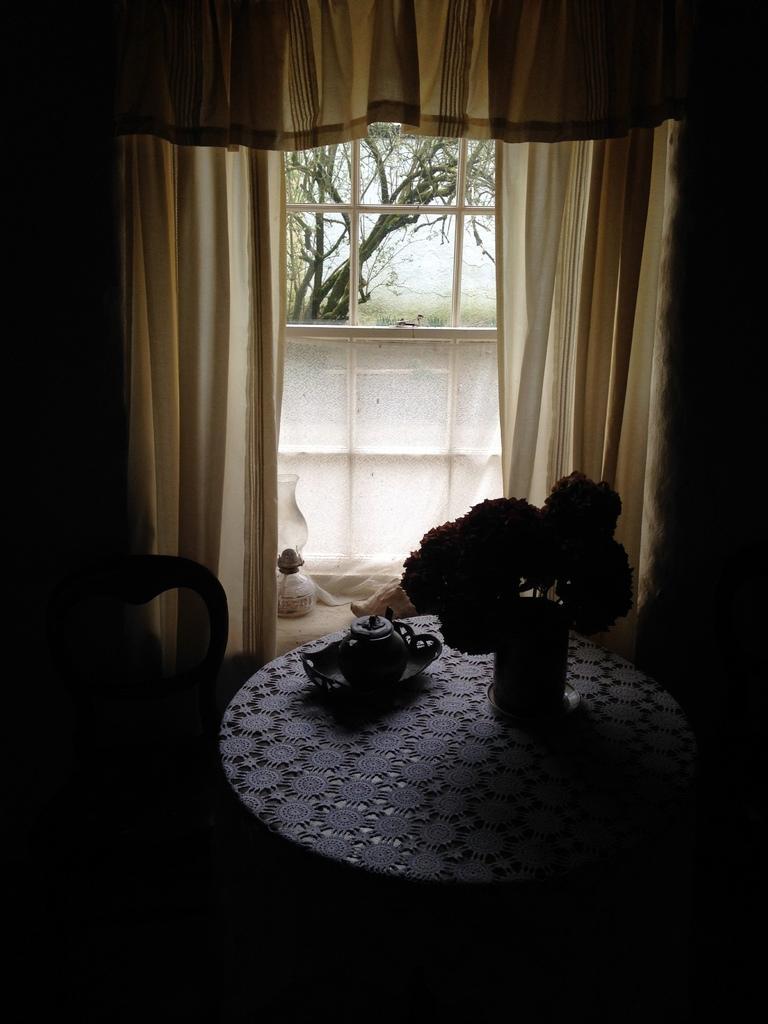In one or two sentences, can you explain what this image depicts? In this image we can see flower vase, pot on a plate on a table and there is a chair, curtains, object on a platform at the window. Through the window glass we can see trees. On the left and right side and at the bottom the image is dark. 